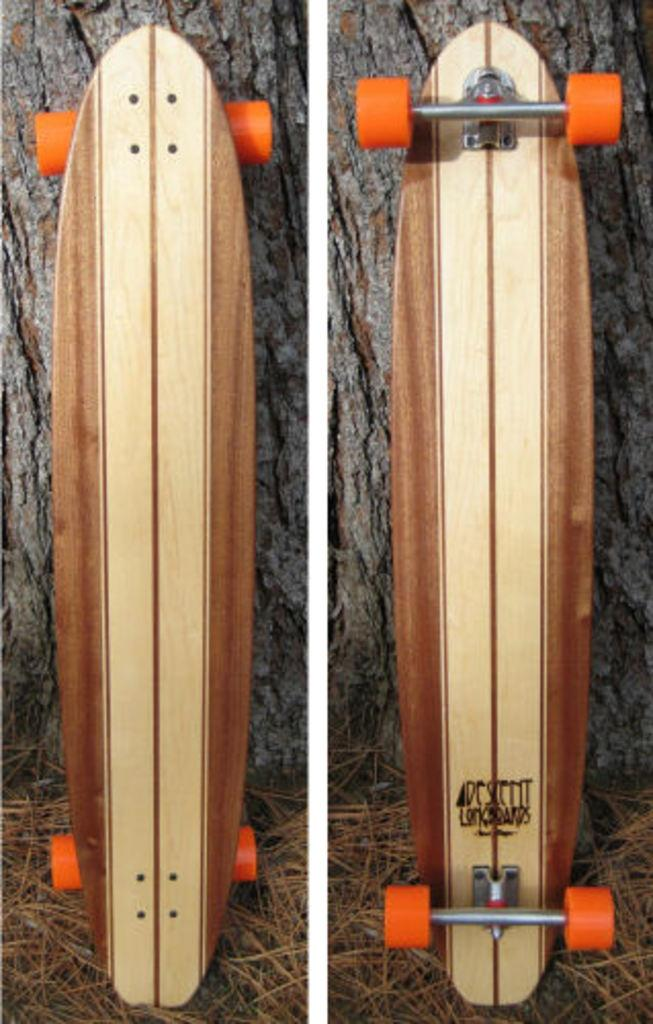What type of artwork is the image? The image is a collage. What object is featured in the collage? There is a skateboard in the image. Where is the skateboard located in the collage? The skateboard is on the ground. How is the skateboard shown in the collage? The skateboard is shown from different angles. What can be seen behind the skateboard in the collage? There is a tree trunk visible behind the skateboard. What color is the lipstick on the skateboard in the image? There is no lipstick present on the skateboard in the image. How much credit is available on the skateboard in the image? The concept of credit is not applicable to a skateboard in the image. --- 